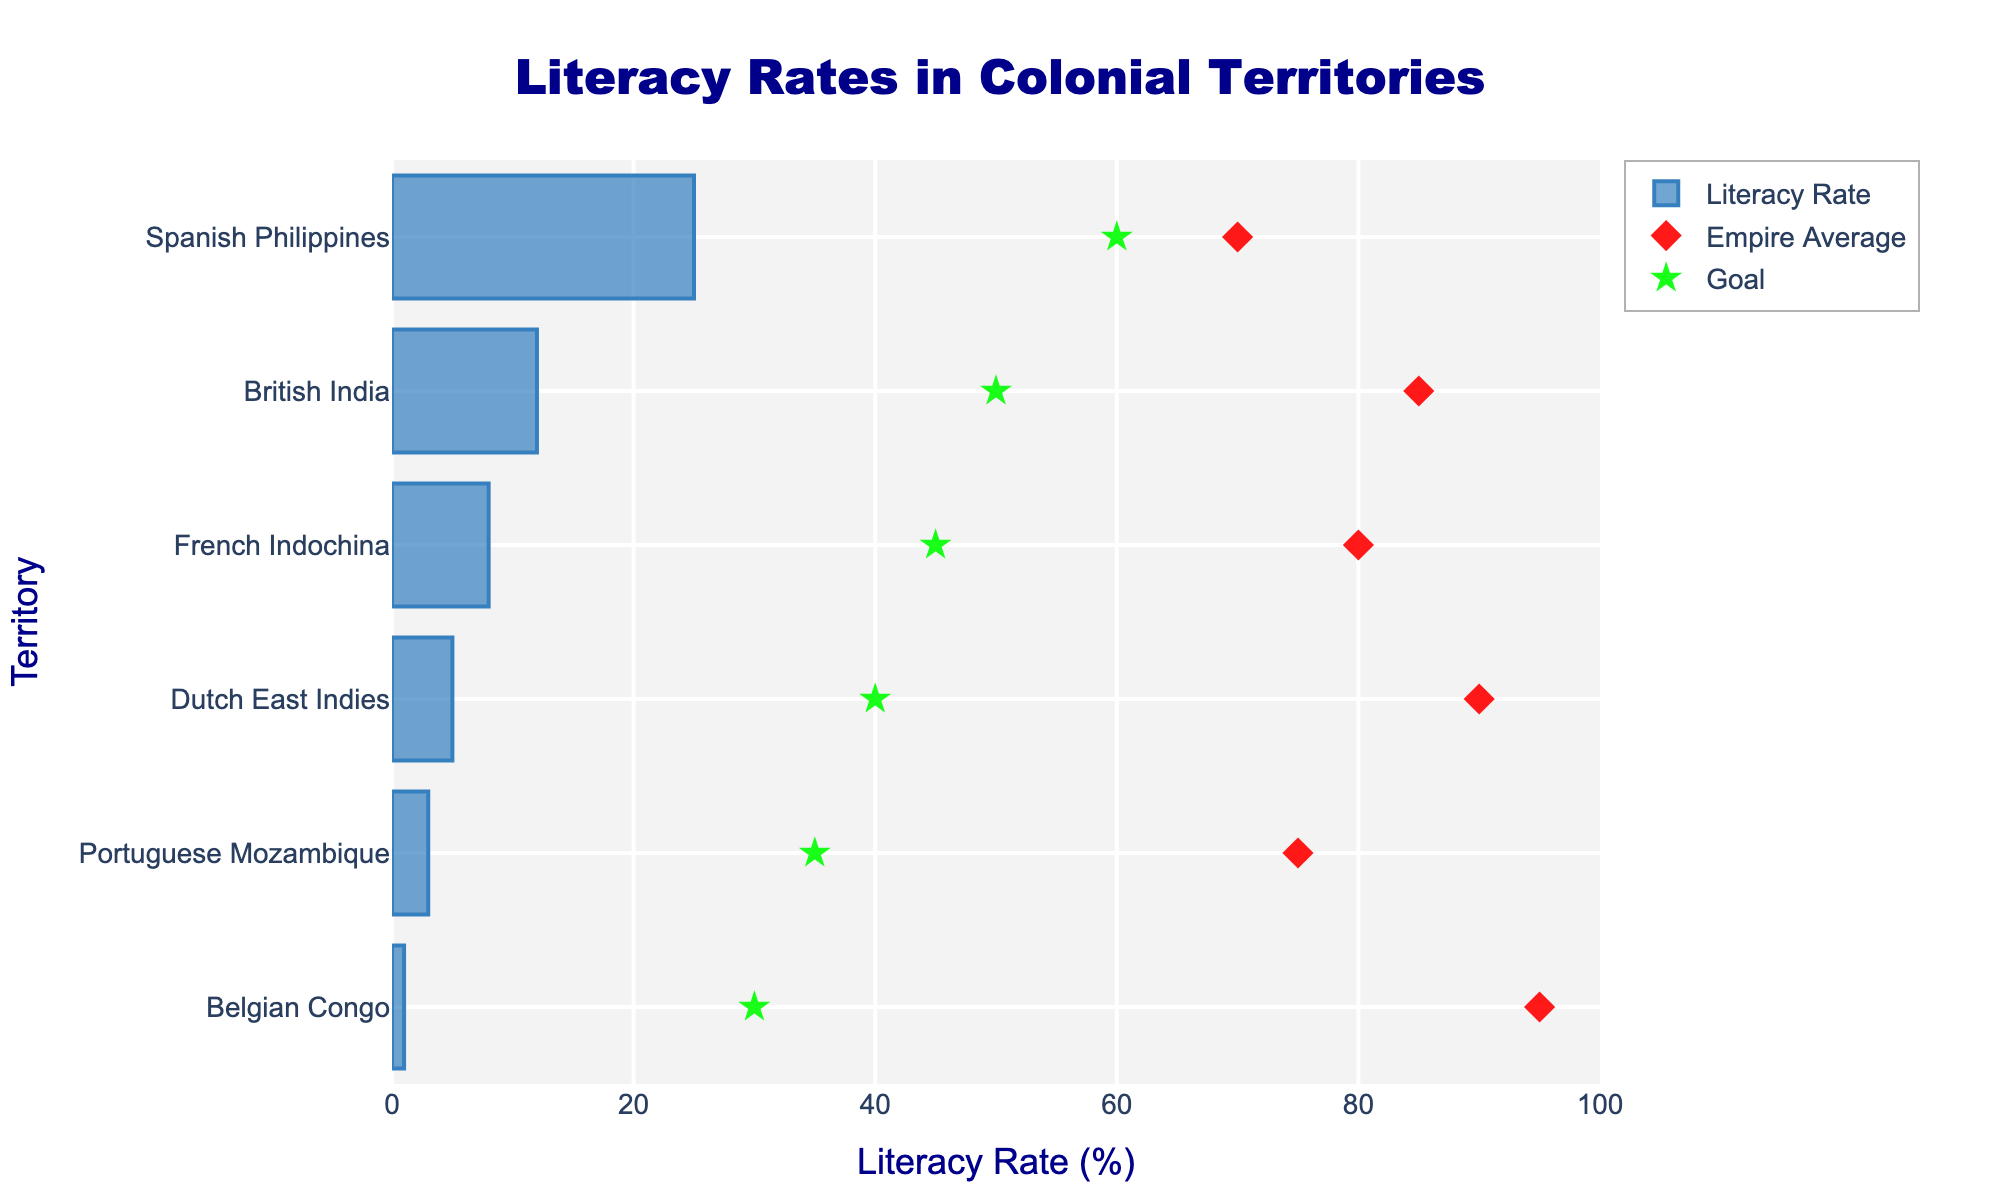what's the title of the figure? The title is usually placed at the top of the figure. By looking at the figure, we see the text 'Literacy Rates in Colonial Territories' as the most prominent heading.
Answer: Literacy Rates in Colonial Territories what is the territory with the lowest literacy rate? By observing the bar representing literacy rates, the smallest bar belongs to 'Belgian Congo' with a literacy rate of 1%.
Answer: Belgian Congo which empire had the highest average literacy rate? By examining the markers indicating empire averages, we notice the diamond marker at the highest position on the x-axis belongs to the 'Belgian Empire' ruling 'Belgian Congo', signifying an average rate of 95%.
Answer: Belgian Empire what is the difference between the literacy rate of British India and its empire average? The literacy rate for British India is 12% and the empire's average is 85%. The difference is calculated as 85% - 12% = 73%.
Answer: 73% which colonial territory achieved the least difference between its literacy rate and its goal? The goal for the Spanish Philippines is 60% and their literacy rate is 25%. The difference is lowest for Spanish Philippines, calculated as 60% - 25% = 35%, which is less than other territories.
Answer: Spanish Philippines compare the literacy rate of Dutch East Indies with French Indochina: which is higher? The bar representing the literacy rate for French Indochina (8%) is longer than the bar for Dutch East Indies (5%). Thus, French Indochina has a higher literacy rate.
Answer: French Indochina what's the average literacy goal across all territories? The goals for all territories are 50%, 40%, 45%, 60%, 35%, and 30%. Adding them: 50 + 40 + 45 + 60 + 35 + 30 = 260. Dividing by the number of territories (6): 260 / 6 = 43.33%.
Answer: 43.33% what does the green star symbol in the figure represent? By examining the plot, the green star symbols are aligned with the text 'Goal' in the legend, signifying the literacy goals for each territory.
Answer: Literacy goals which two territories have the widest gap between their literacy rate and their empire average? By calculating the difference for each pair: British India (73%), Dutch East Indies (85%), French Indochina (72%), Spanish Philippines (45%), Portuguese Mozambique (72%), Belgian Congo (94%). The Belgian Congo (94%) and Dutch East Indies (85%) show the widest gaps.
Answer: Belgian Congo and Dutch East Indies 